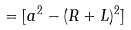<formula> <loc_0><loc_0><loc_500><loc_500>= [ a ^ { 2 } - ( R + L ) ^ { 2 } ]</formula> 